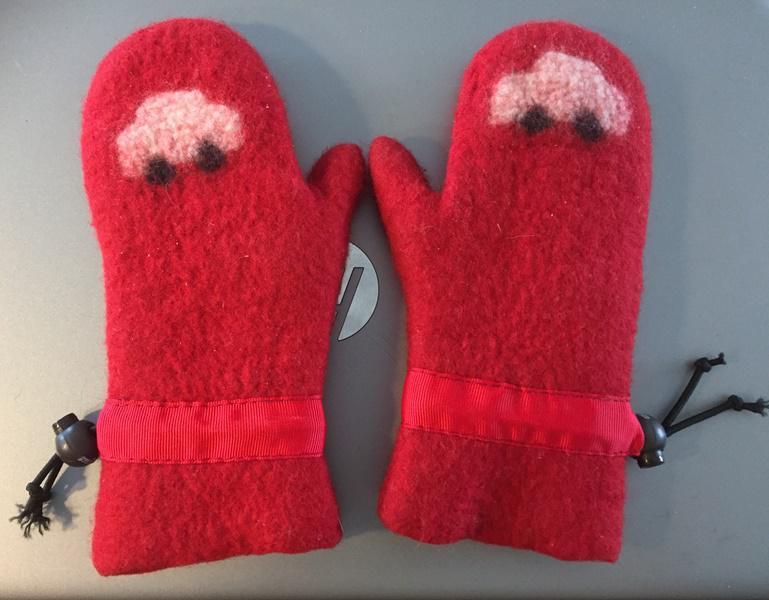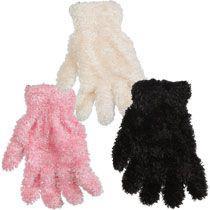The first image is the image on the left, the second image is the image on the right. Analyze the images presented: Is the assertion "An image shows exactly three unworn items of apparel, and at least two are gloves with fingers." valid? Answer yes or no. Yes. The first image is the image on the left, the second image is the image on the right. Examine the images to the left and right. Is the description "The left and right image contains the same number of red mittens." accurate? Answer yes or no. No. 